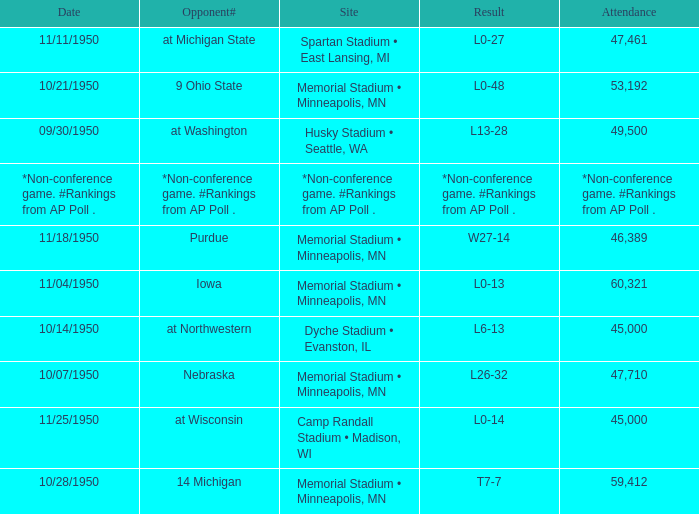What is the Date when the result is *non-conference game. #rankings from ap poll .? *Non-conference game. #Rankings from AP Poll . 